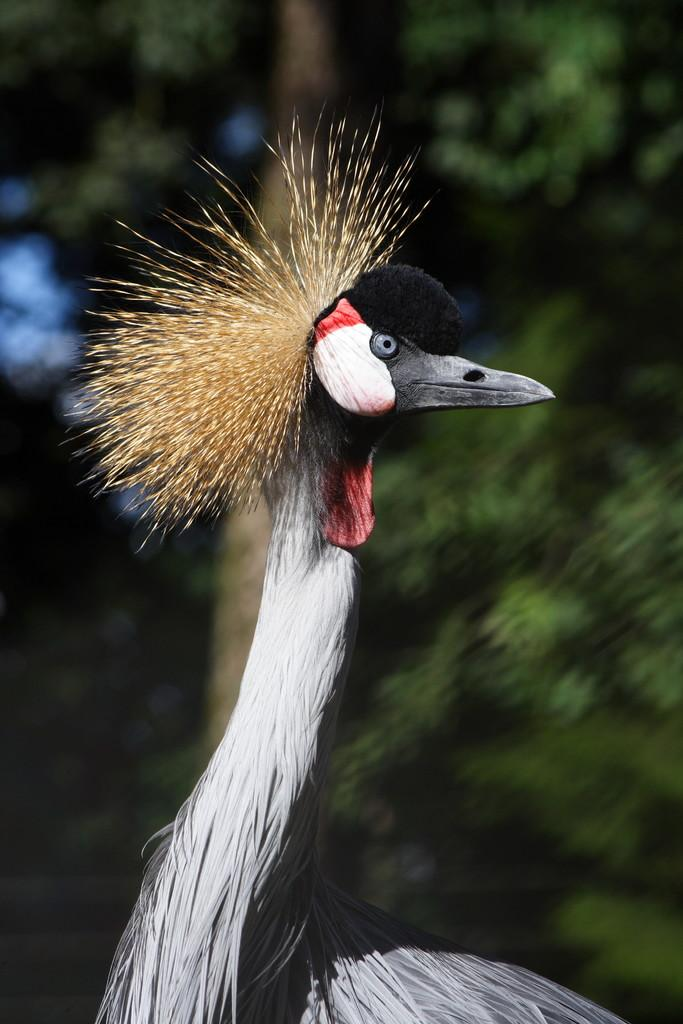What is the main subject in the foreground of the image? There is a bird in the foreground of the image. What can be seen in the background of the image? There is a tree in the background of the image. How does the beggar interact with the bird in the image? There is no beggar present in the image, so no interaction can be observed. 